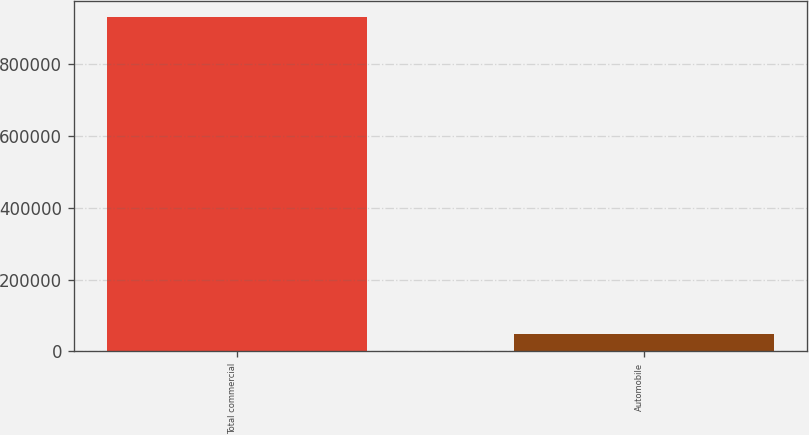Convert chart. <chart><loc_0><loc_0><loc_500><loc_500><bar_chart><fcel>Total commercial<fcel>Automobile<nl><fcel>928865<fcel>49488<nl></chart> 